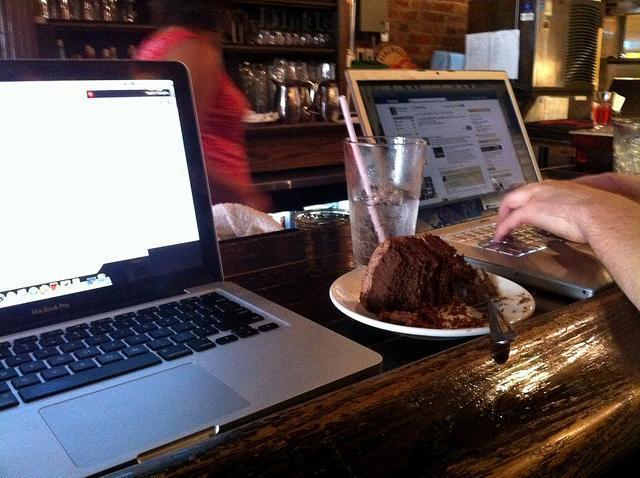How many laptops can be seen?
Give a very brief answer. 2. How many people can you see?
Give a very brief answer. 2. How many cakes are there?
Give a very brief answer. 1. How many people on the vase are holding a vase?
Give a very brief answer. 0. 